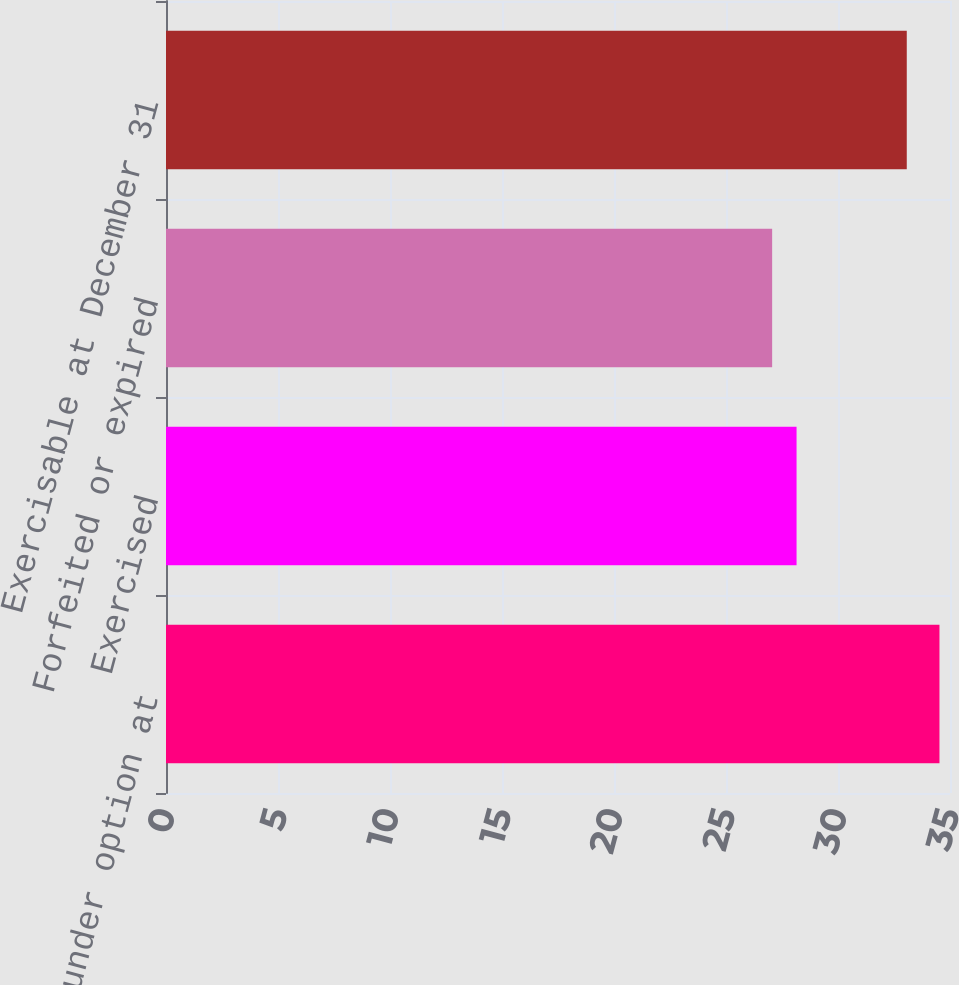Convert chart. <chart><loc_0><loc_0><loc_500><loc_500><bar_chart><fcel>Shares under option at<fcel>Exercised<fcel>Forfeited or expired<fcel>Exercisable at December 31<nl><fcel>34.53<fcel>28.15<fcel>27.06<fcel>33.07<nl></chart> 